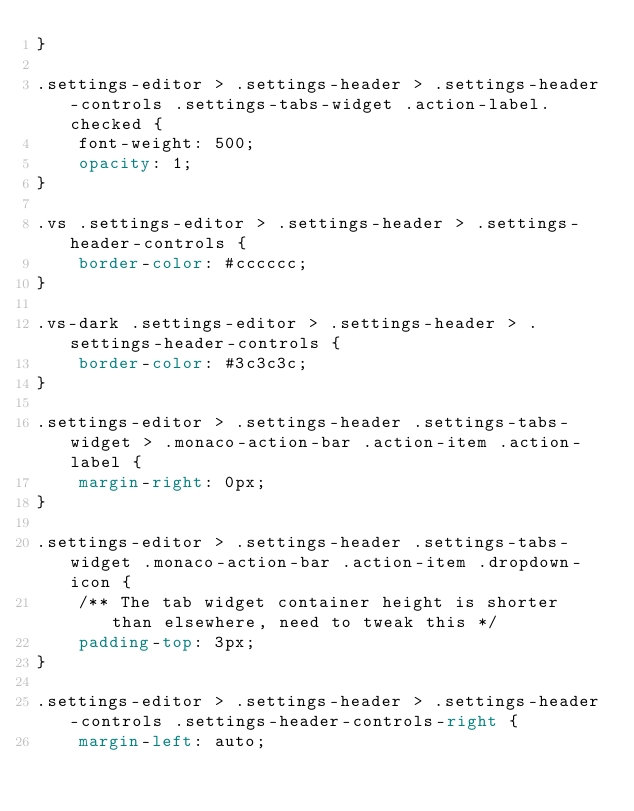Convert code to text. <code><loc_0><loc_0><loc_500><loc_500><_CSS_>}

.settings-editor > .settings-header > .settings-header-controls .settings-tabs-widget .action-label.checked {
	font-weight: 500;
	opacity: 1;
}

.vs .settings-editor > .settings-header > .settings-header-controls {
	border-color: #cccccc;
}

.vs-dark .settings-editor > .settings-header > .settings-header-controls {
	border-color: #3c3c3c;
}

.settings-editor > .settings-header .settings-tabs-widget > .monaco-action-bar .action-item .action-label {
	margin-right: 0px;
}

.settings-editor > .settings-header .settings-tabs-widget .monaco-action-bar .action-item .dropdown-icon {
	/** The tab widget container height is shorter than elsewhere, need to tweak this */
	padding-top: 3px;
}

.settings-editor > .settings-header > .settings-header-controls .settings-header-controls-right {
	margin-left: auto;</code> 